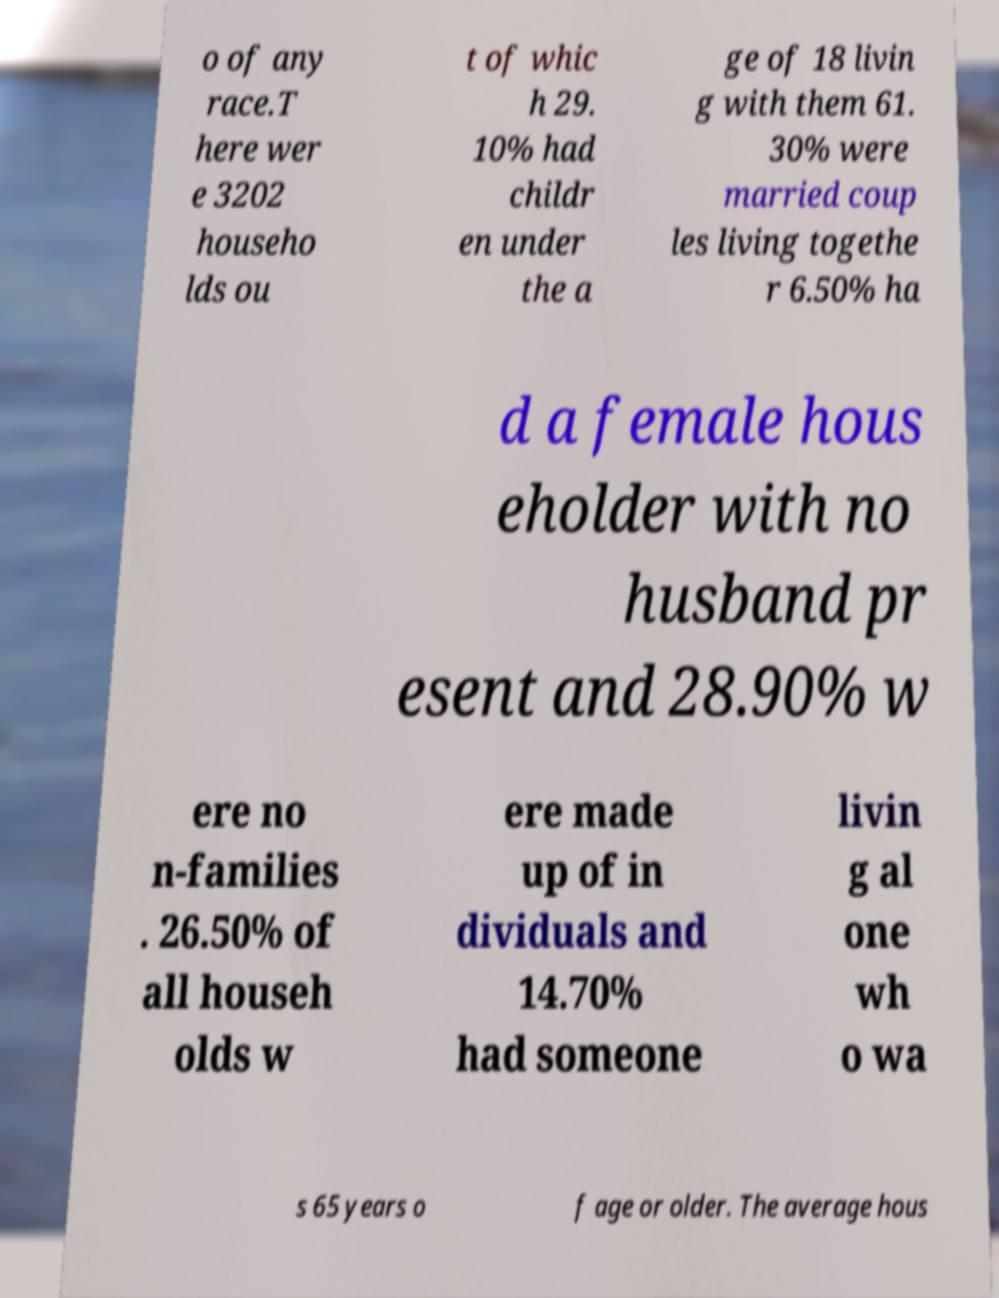There's text embedded in this image that I need extracted. Can you transcribe it verbatim? o of any race.T here wer e 3202 househo lds ou t of whic h 29. 10% had childr en under the a ge of 18 livin g with them 61. 30% were married coup les living togethe r 6.50% ha d a female hous eholder with no husband pr esent and 28.90% w ere no n-families . 26.50% of all househ olds w ere made up of in dividuals and 14.70% had someone livin g al one wh o wa s 65 years o f age or older. The average hous 